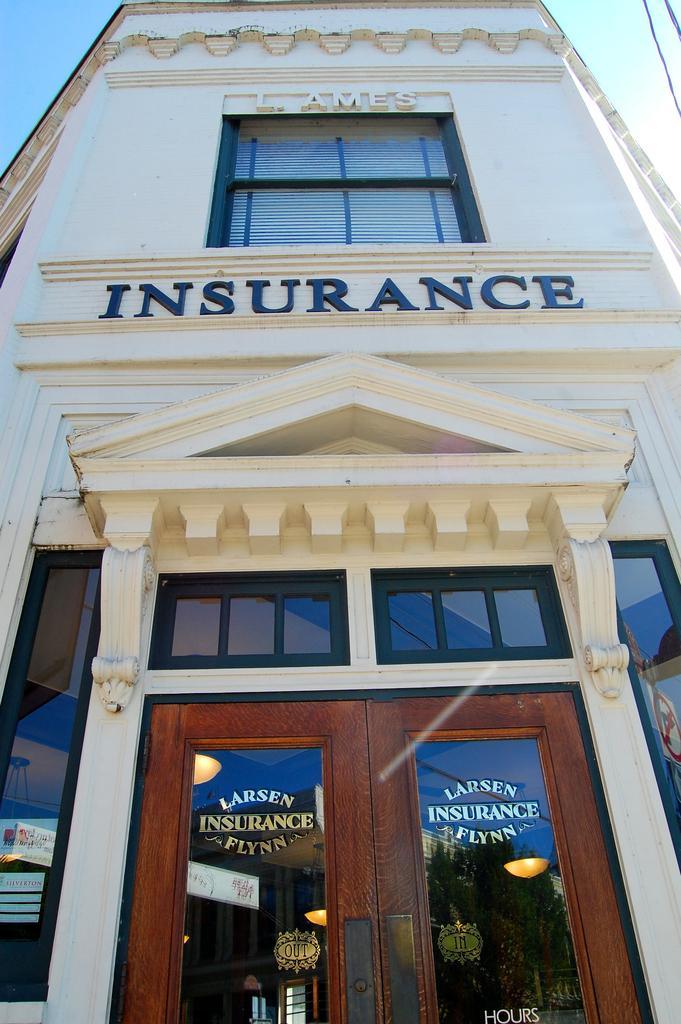Please provide a concise description of this image. In this image I see a building and I see the doors over here on which there are words written and through the glasses I see the lights and I see 2 words written on this building. In the background I see the blue sky. 